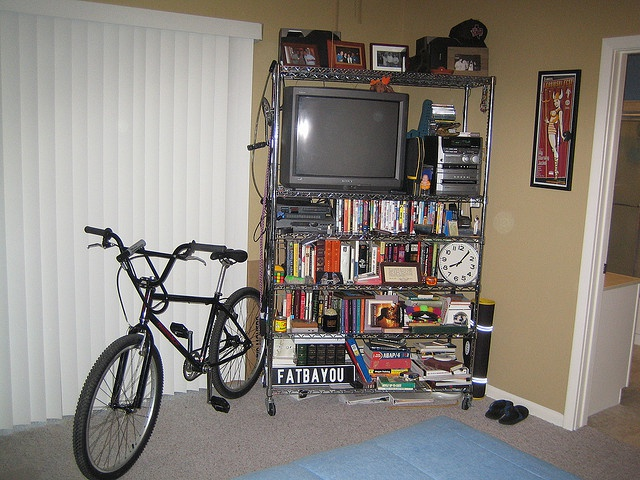Describe the objects in this image and their specific colors. I can see bicycle in gray, black, lightgray, and darkgray tones, book in gray, black, darkgray, and lightgray tones, tv in gray and black tones, book in gray, black, darkgray, and maroon tones, and clock in gray, lightgray, and darkgray tones in this image. 